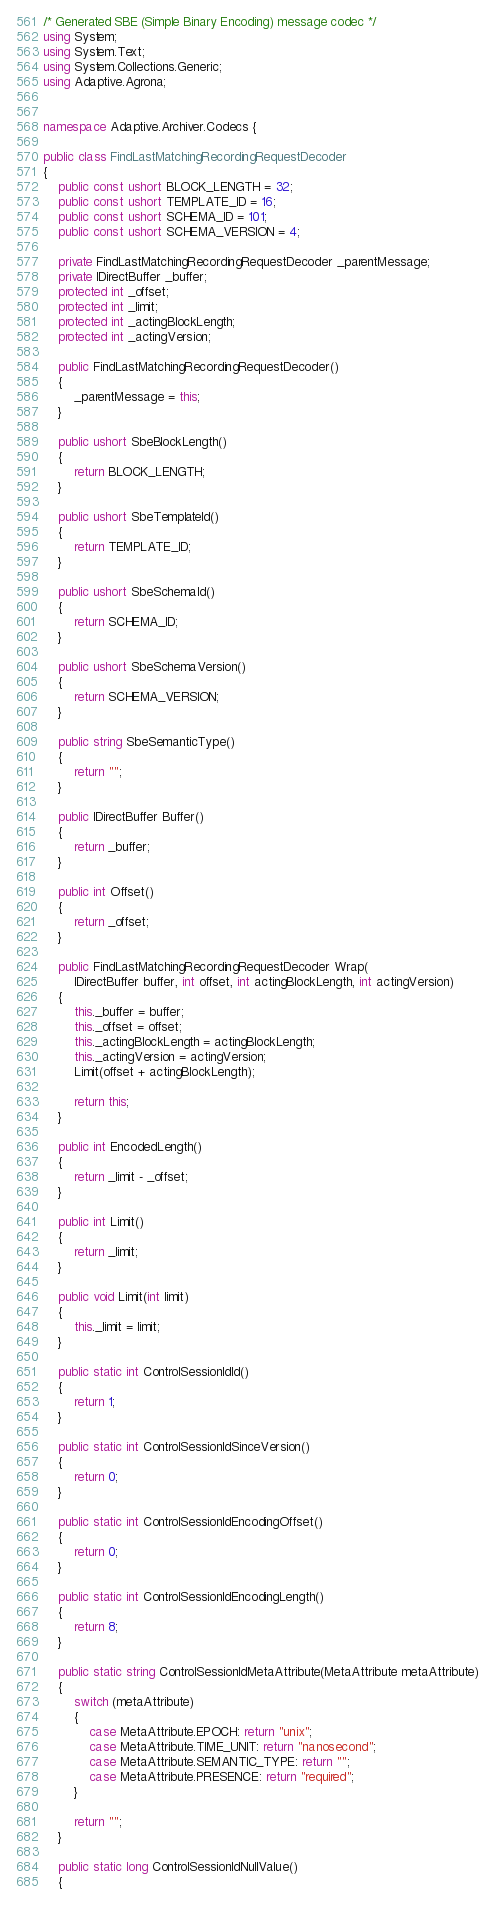<code> <loc_0><loc_0><loc_500><loc_500><_C#_>/* Generated SBE (Simple Binary Encoding) message codec */
using System;
using System.Text;
using System.Collections.Generic;
using Adaptive.Agrona;


namespace Adaptive.Archiver.Codecs {

public class FindLastMatchingRecordingRequestDecoder
{
    public const ushort BLOCK_LENGTH = 32;
    public const ushort TEMPLATE_ID = 16;
    public const ushort SCHEMA_ID = 101;
    public const ushort SCHEMA_VERSION = 4;

    private FindLastMatchingRecordingRequestDecoder _parentMessage;
    private IDirectBuffer _buffer;
    protected int _offset;
    protected int _limit;
    protected int _actingBlockLength;
    protected int _actingVersion;

    public FindLastMatchingRecordingRequestDecoder()
    {
        _parentMessage = this;
    }

    public ushort SbeBlockLength()
    {
        return BLOCK_LENGTH;
    }

    public ushort SbeTemplateId()
    {
        return TEMPLATE_ID;
    }

    public ushort SbeSchemaId()
    {
        return SCHEMA_ID;
    }

    public ushort SbeSchemaVersion()
    {
        return SCHEMA_VERSION;
    }

    public string SbeSemanticType()
    {
        return "";
    }

    public IDirectBuffer Buffer()
    {
        return _buffer;
    }

    public int Offset()
    {
        return _offset;
    }

    public FindLastMatchingRecordingRequestDecoder Wrap(
        IDirectBuffer buffer, int offset, int actingBlockLength, int actingVersion)
    {
        this._buffer = buffer;
        this._offset = offset;
        this._actingBlockLength = actingBlockLength;
        this._actingVersion = actingVersion;
        Limit(offset + actingBlockLength);

        return this;
    }

    public int EncodedLength()
    {
        return _limit - _offset;
    }

    public int Limit()
    {
        return _limit;
    }

    public void Limit(int limit)
    {
        this._limit = limit;
    }

    public static int ControlSessionIdId()
    {
        return 1;
    }

    public static int ControlSessionIdSinceVersion()
    {
        return 0;
    }

    public static int ControlSessionIdEncodingOffset()
    {
        return 0;
    }

    public static int ControlSessionIdEncodingLength()
    {
        return 8;
    }

    public static string ControlSessionIdMetaAttribute(MetaAttribute metaAttribute)
    {
        switch (metaAttribute)
        {
            case MetaAttribute.EPOCH: return "unix";
            case MetaAttribute.TIME_UNIT: return "nanosecond";
            case MetaAttribute.SEMANTIC_TYPE: return "";
            case MetaAttribute.PRESENCE: return "required";
        }

        return "";
    }

    public static long ControlSessionIdNullValue()
    {</code> 